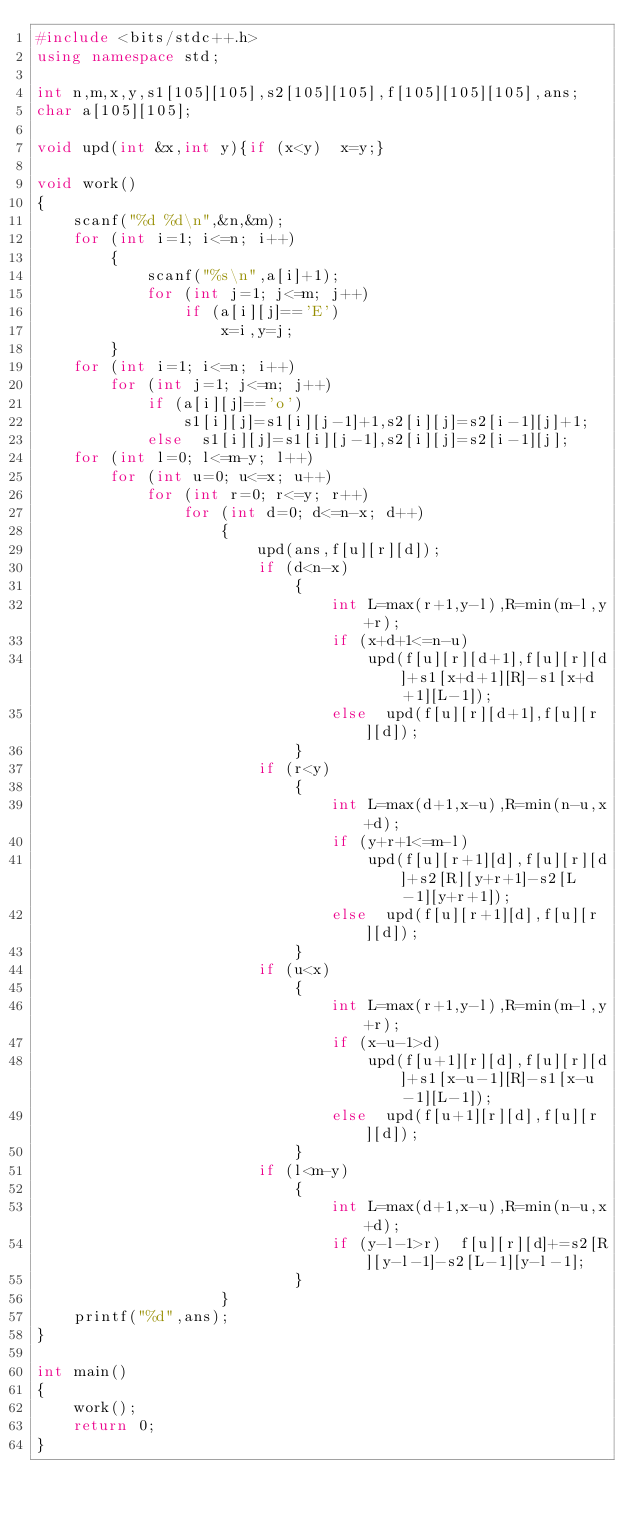Convert code to text. <code><loc_0><loc_0><loc_500><loc_500><_C++_>#include <bits/stdc++.h>
using namespace std;

int n,m,x,y,s1[105][105],s2[105][105],f[105][105][105],ans;
char a[105][105];

void upd(int &x,int y){if (x<y)  x=y;}

void work()
{
	scanf("%d %d\n",&n,&m);
	for (int i=1; i<=n; i++)
		{
			scanf("%s\n",a[i]+1);
			for (int j=1; j<=m; j++)
				if (a[i][j]=='E')
					x=i,y=j;
		}
	for (int i=1; i<=n; i++)
		for (int j=1; j<=m; j++)
			if (a[i][j]=='o')
				s1[i][j]=s1[i][j-1]+1,s2[i][j]=s2[i-1][j]+1;
			else  s1[i][j]=s1[i][j-1],s2[i][j]=s2[i-1][j];
	for (int l=0; l<=m-y; l++)
		for (int u=0; u<=x; u++)
			for (int r=0; r<=y; r++)
				for (int d=0; d<=n-x; d++)
					{
						upd(ans,f[u][r][d]);
						if (d<n-x)
							{
								int L=max(r+1,y-l),R=min(m-l,y+r);
								if (x+d+1<=n-u)
									upd(f[u][r][d+1],f[u][r][d]+s1[x+d+1][R]-s1[x+d+1][L-1]);
								else  upd(f[u][r][d+1],f[u][r][d]);
							}
						if (r<y)
							{
								int L=max(d+1,x-u),R=min(n-u,x+d);
								if (y+r+1<=m-l)
									upd(f[u][r+1][d],f[u][r][d]+s2[R][y+r+1]-s2[L-1][y+r+1]);
								else  upd(f[u][r+1][d],f[u][r][d]);
							}
						if (u<x)
							{
								int L=max(r+1,y-l),R=min(m-l,y+r);
								if (x-u-1>d)
									upd(f[u+1][r][d],f[u][r][d]+s1[x-u-1][R]-s1[x-u-1][L-1]);
								else  upd(f[u+1][r][d],f[u][r][d]);
							}
						if (l<m-y)
							{
								int L=max(d+1,x-u),R=min(n-u,x+d);
								if (y-l-1>r)  f[u][r][d]+=s2[R][y-l-1]-s2[L-1][y-l-1];
							}
					}
	printf("%d",ans);
}

int main()
{
	work();
	return 0;
}
</code> 